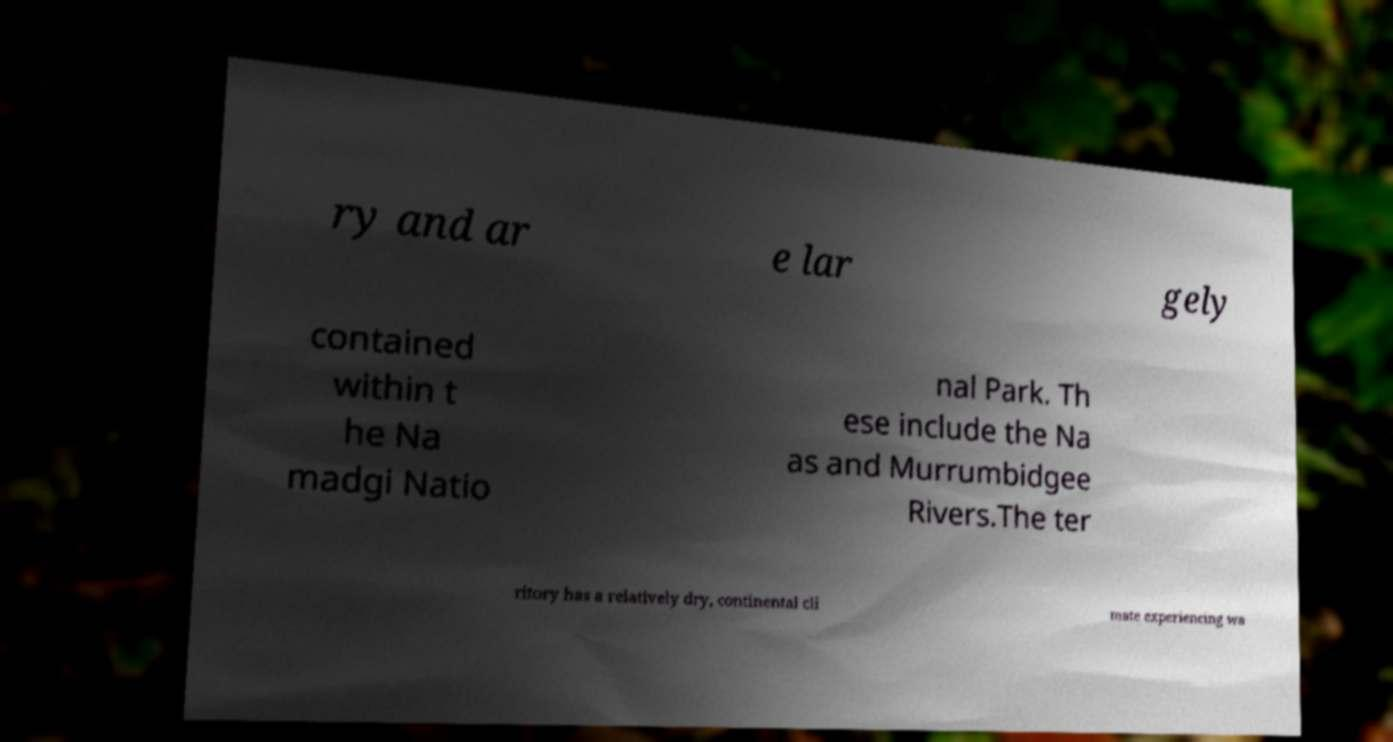Can you read and provide the text displayed in the image?This photo seems to have some interesting text. Can you extract and type it out for me? ry and ar e lar gely contained within t he Na madgi Natio nal Park. Th ese include the Na as and Murrumbidgee Rivers.The ter ritory has a relatively dry, continental cli mate experiencing wa 